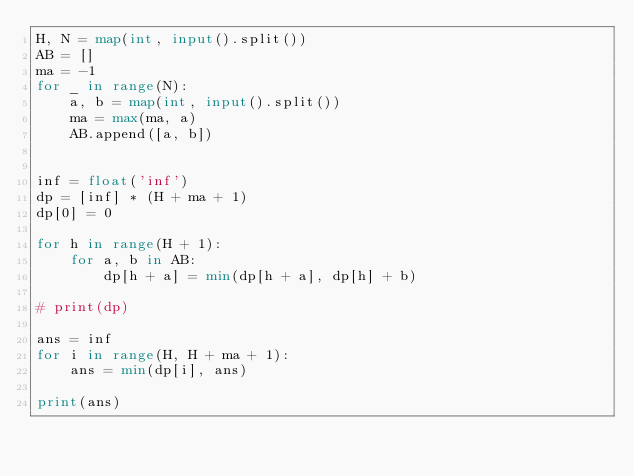Convert code to text. <code><loc_0><loc_0><loc_500><loc_500><_Python_>H, N = map(int, input().split())
AB = []
ma = -1
for _ in range(N):
    a, b = map(int, input().split())
    ma = max(ma, a)
    AB.append([a, b])


inf = float('inf')
dp = [inf] * (H + ma + 1)
dp[0] = 0

for h in range(H + 1):
    for a, b in AB:
        dp[h + a] = min(dp[h + a], dp[h] + b)

# print(dp)

ans = inf
for i in range(H, H + ma + 1):
    ans = min(dp[i], ans)

print(ans)
</code> 